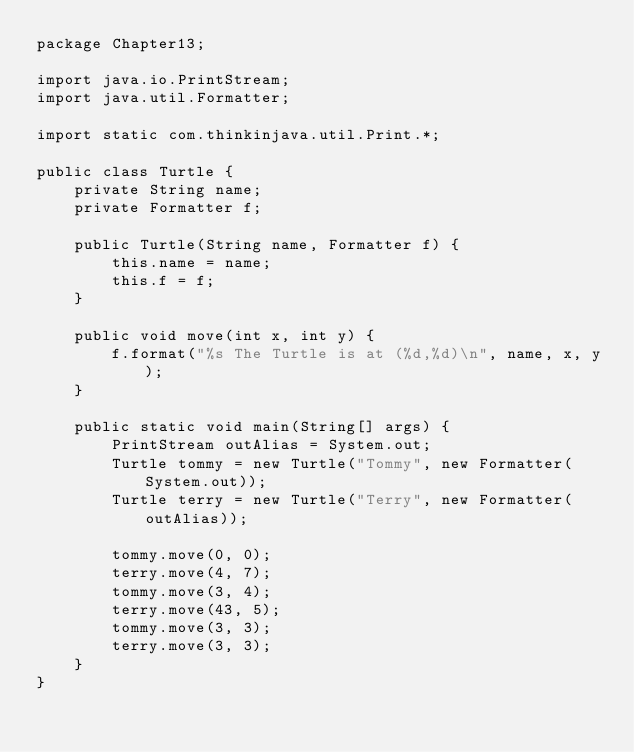<code> <loc_0><loc_0><loc_500><loc_500><_Java_>package Chapter13;

import java.io.PrintStream;
import java.util.Formatter;

import static com.thinkinjava.util.Print.*;

public class Turtle {
    private String name;
    private Formatter f;

    public Turtle(String name, Formatter f) {
        this.name = name;
        this.f = f;
    }

    public void move(int x, int y) {
        f.format("%s The Turtle is at (%d,%d)\n", name, x, y);
    }

    public static void main(String[] args) {
        PrintStream outAlias = System.out;
        Turtle tommy = new Turtle("Tommy", new Formatter(System.out));
        Turtle terry = new Turtle("Terry", new Formatter(outAlias));

        tommy.move(0, 0);
        terry.move(4, 7);
        tommy.move(3, 4);
        terry.move(43, 5);
        tommy.move(3, 3);
        terry.move(3, 3);
    }
}
</code> 